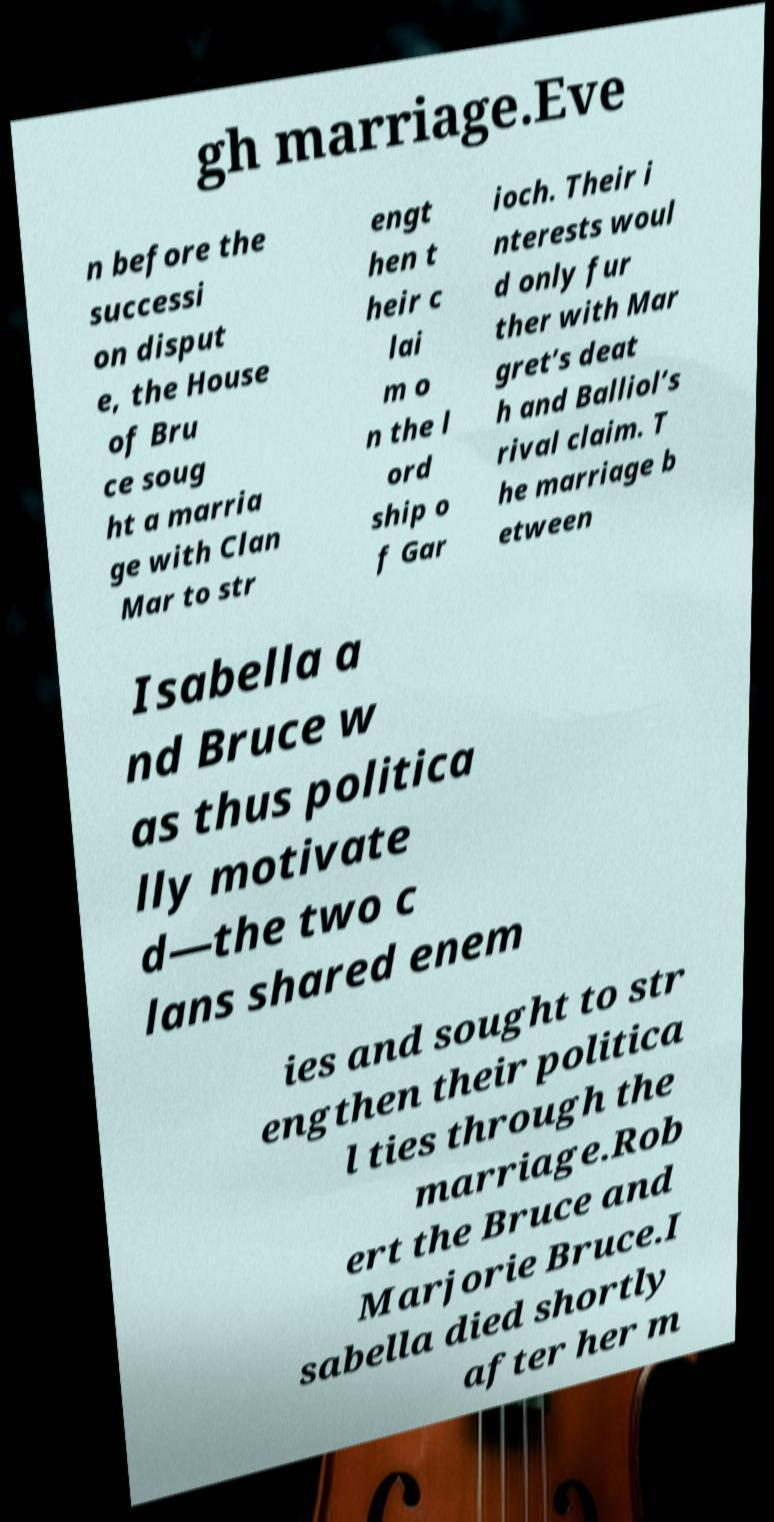I need the written content from this picture converted into text. Can you do that? gh marriage.Eve n before the successi on disput e, the House of Bru ce soug ht a marria ge with Clan Mar to str engt hen t heir c lai m o n the l ord ship o f Gar ioch. Their i nterests woul d only fur ther with Mar gret’s deat h and Balliol’s rival claim. T he marriage b etween Isabella a nd Bruce w as thus politica lly motivate d—the two c lans shared enem ies and sought to str engthen their politica l ties through the marriage.Rob ert the Bruce and Marjorie Bruce.I sabella died shortly after her m 